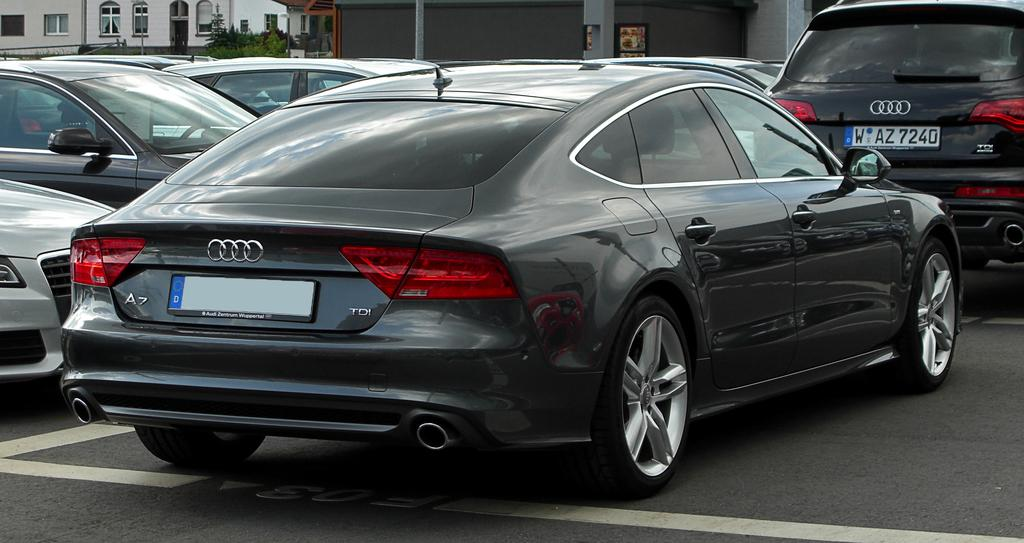<image>
Describe the image concisely. The SUV in front of the car has the plate number WAZ7240. 